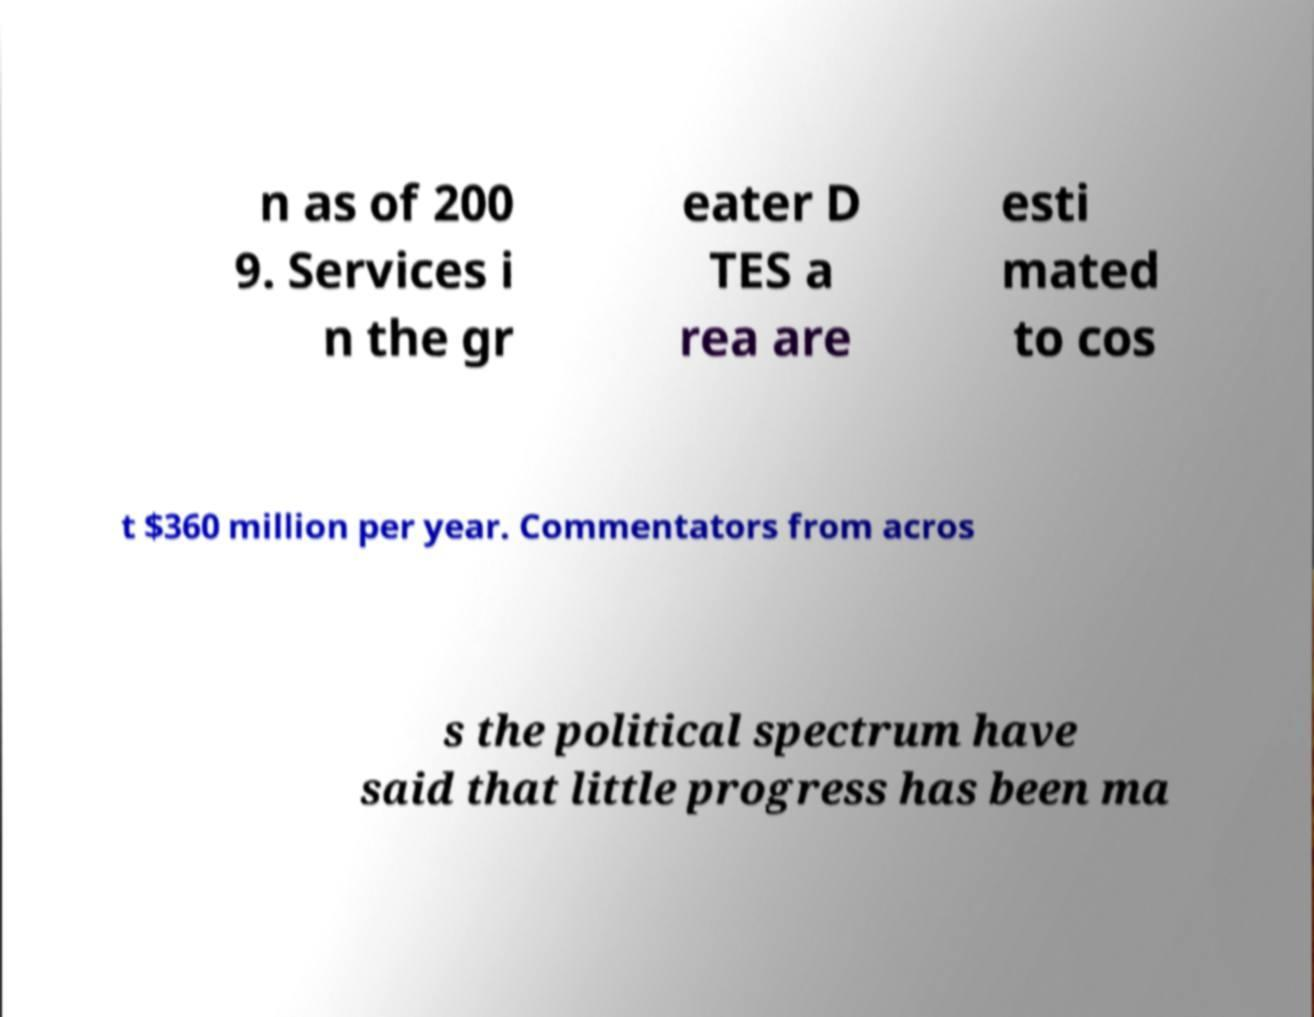Please identify and transcribe the text found in this image. n as of 200 9. Services i n the gr eater D TES a rea are esti mated to cos t $360 million per year. Commentators from acros s the political spectrum have said that little progress has been ma 